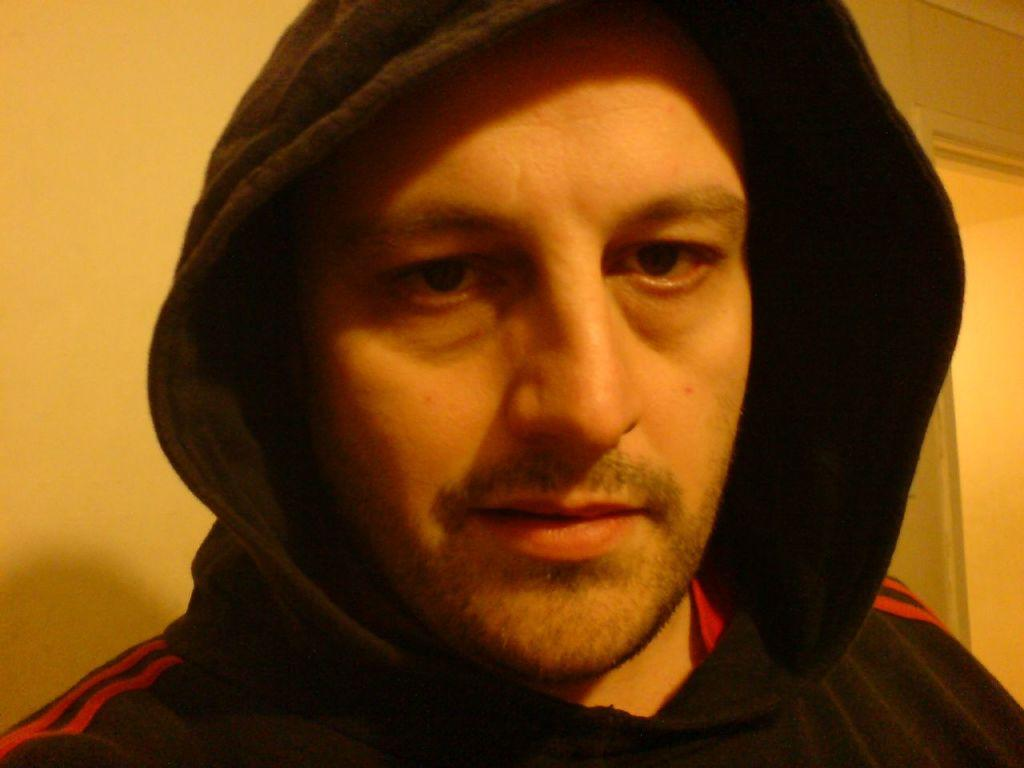What is the main subject of the image? There is a person in the image. Can you describe the background of the image? There is a wall behind the person in the image. How much wealth does the cup in the image contain? There is no cup present in the image, so it is not possible to determine its wealth. 